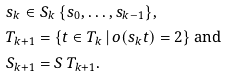<formula> <loc_0><loc_0><loc_500><loc_500>& s _ { k } \in S _ { k } \ \{ s _ { 0 } , \dots , s _ { k - 1 } \} , \\ & T _ { k + 1 } = \{ t \in T _ { k } \, | \, o ( s _ { k } t ) = 2 \} \ \text {and} \\ & S _ { k + 1 } = S \ T _ { k + 1 } .</formula> 